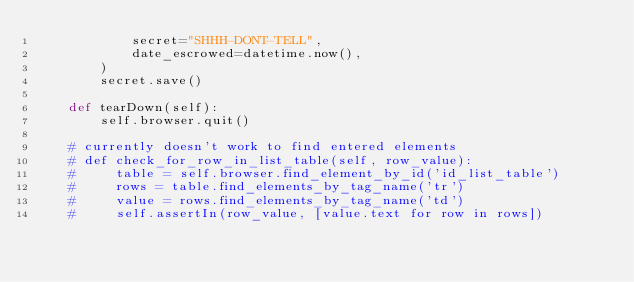<code> <loc_0><loc_0><loc_500><loc_500><_Python_>            secret="SHHH-DONT-TELL",
            date_escrowed=datetime.now(),
        )
        secret.save()

    def tearDown(self):
        self.browser.quit()

    # currently doesn't work to find entered elements
    # def check_for_row_in_list_table(self, row_value):
    #     table = self.browser.find_element_by_id('id_list_table')
    #     rows = table.find_elements_by_tag_name('tr')
    #     value = rows.find_elements_by_tag_name('td')
    #     self.assertIn(row_value, [value.text for row in rows])
</code> 